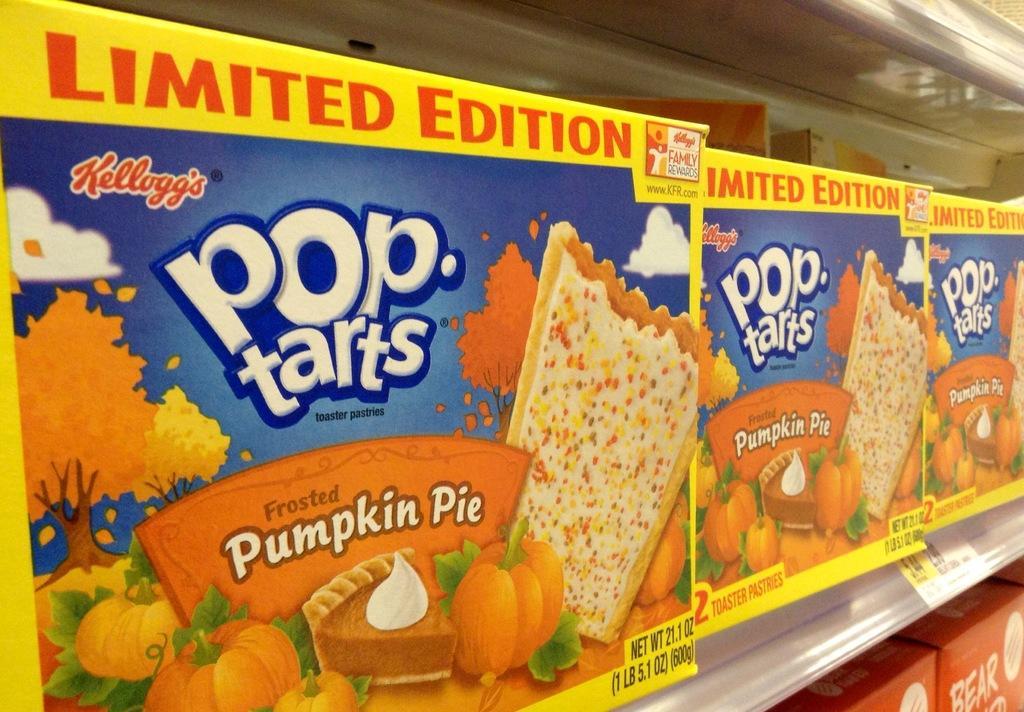Could you give a brief overview of what you see in this image? In the image there are few packets with images and there is something written on it. Those packets are in the racks. And also there is a price attached on the rack. 